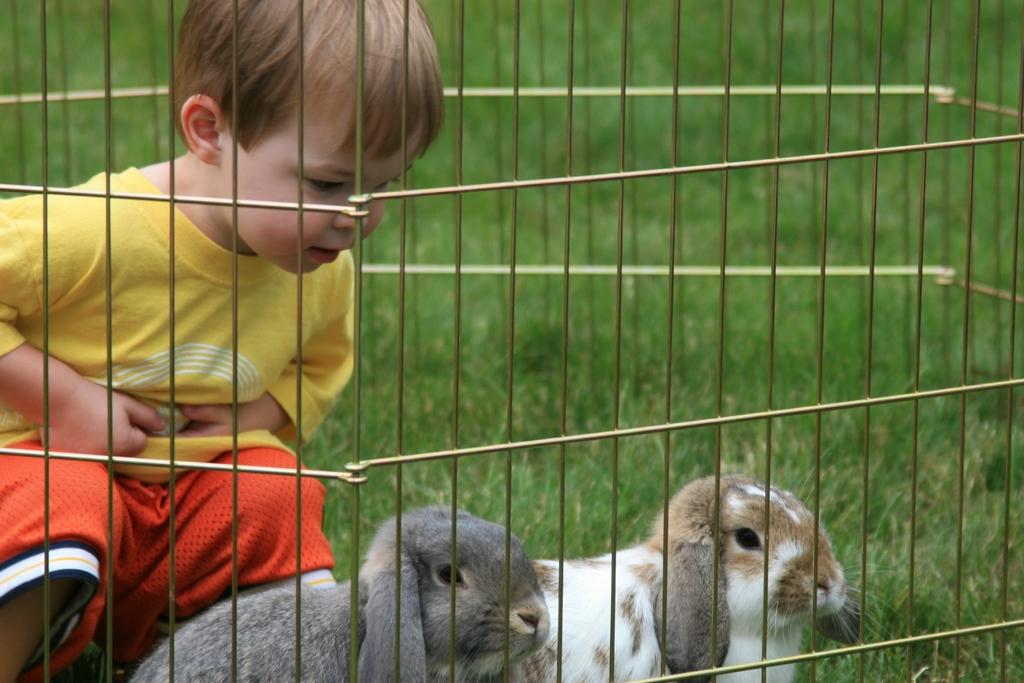Who is the main subject in the image? There is a boy in the image. Where is the boy located in the image? The boy is on the left side of the image. What is the boy wearing? The boy is wearing a t-shirt and trousers. What else can be seen in the image besides the boy? There is a box in the image, and there are two rabbits inside the box. What is visible in the background of the image? There is grass in the background of the image. What is the boy doing with his body in the image? The image does not show the boy doing anything with his body; he is simply standing on the left side of the image. How many points does the box have in the image? The box in the image is a rectangular shape and does not have any points. 